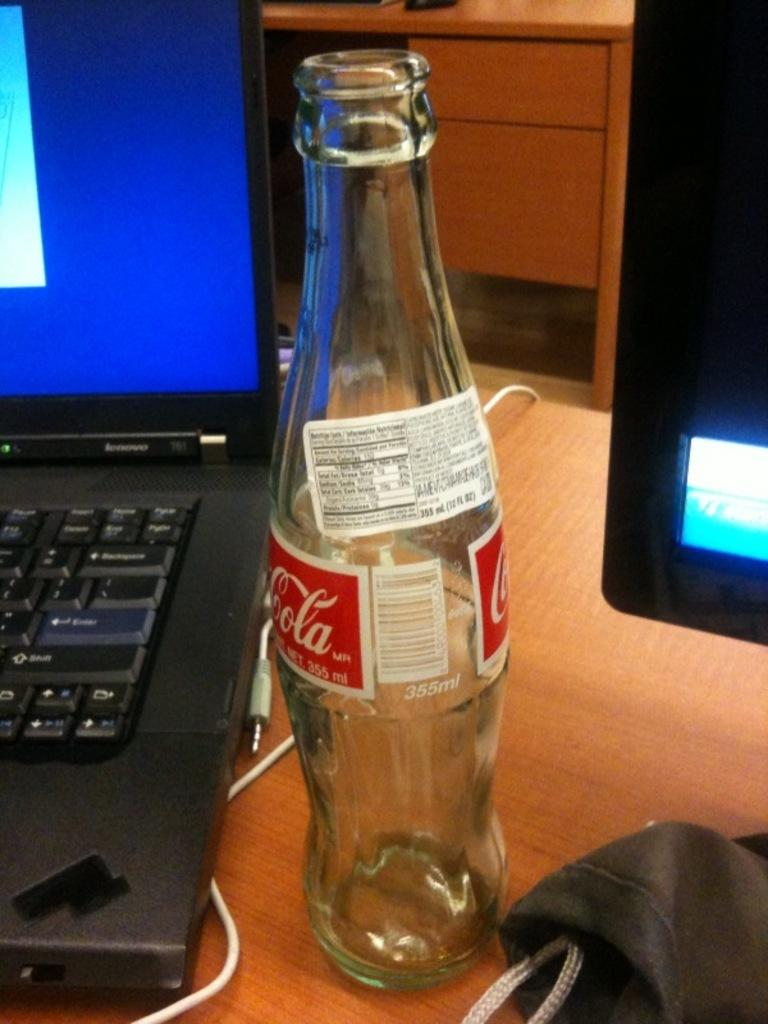<image>
Write a terse but informative summary of the picture. An empty bottle of coca cola is in between a laptop and a monitor. 